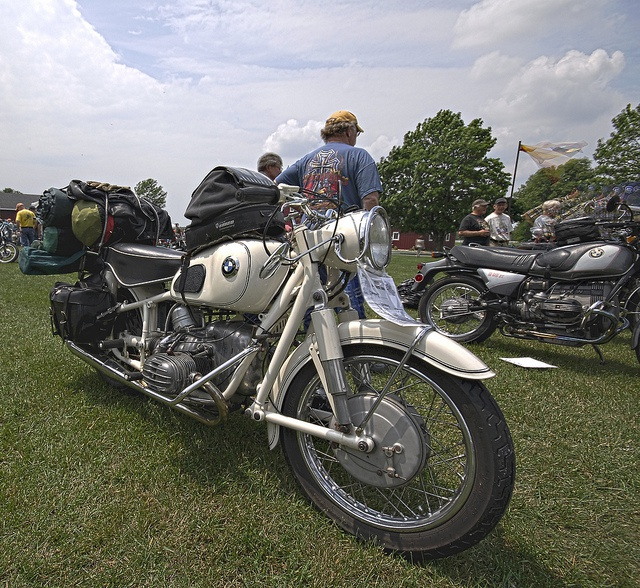Describe the objects in this image and their specific colors. I can see motorcycle in white, black, gray, and darkgray tones, motorcycle in white, black, gray, darkgray, and darkgreen tones, people in white, gray, and black tones, backpack in white, black, gray, darkgray, and lightgray tones, and handbag in white, black, gray, and darkgray tones in this image. 